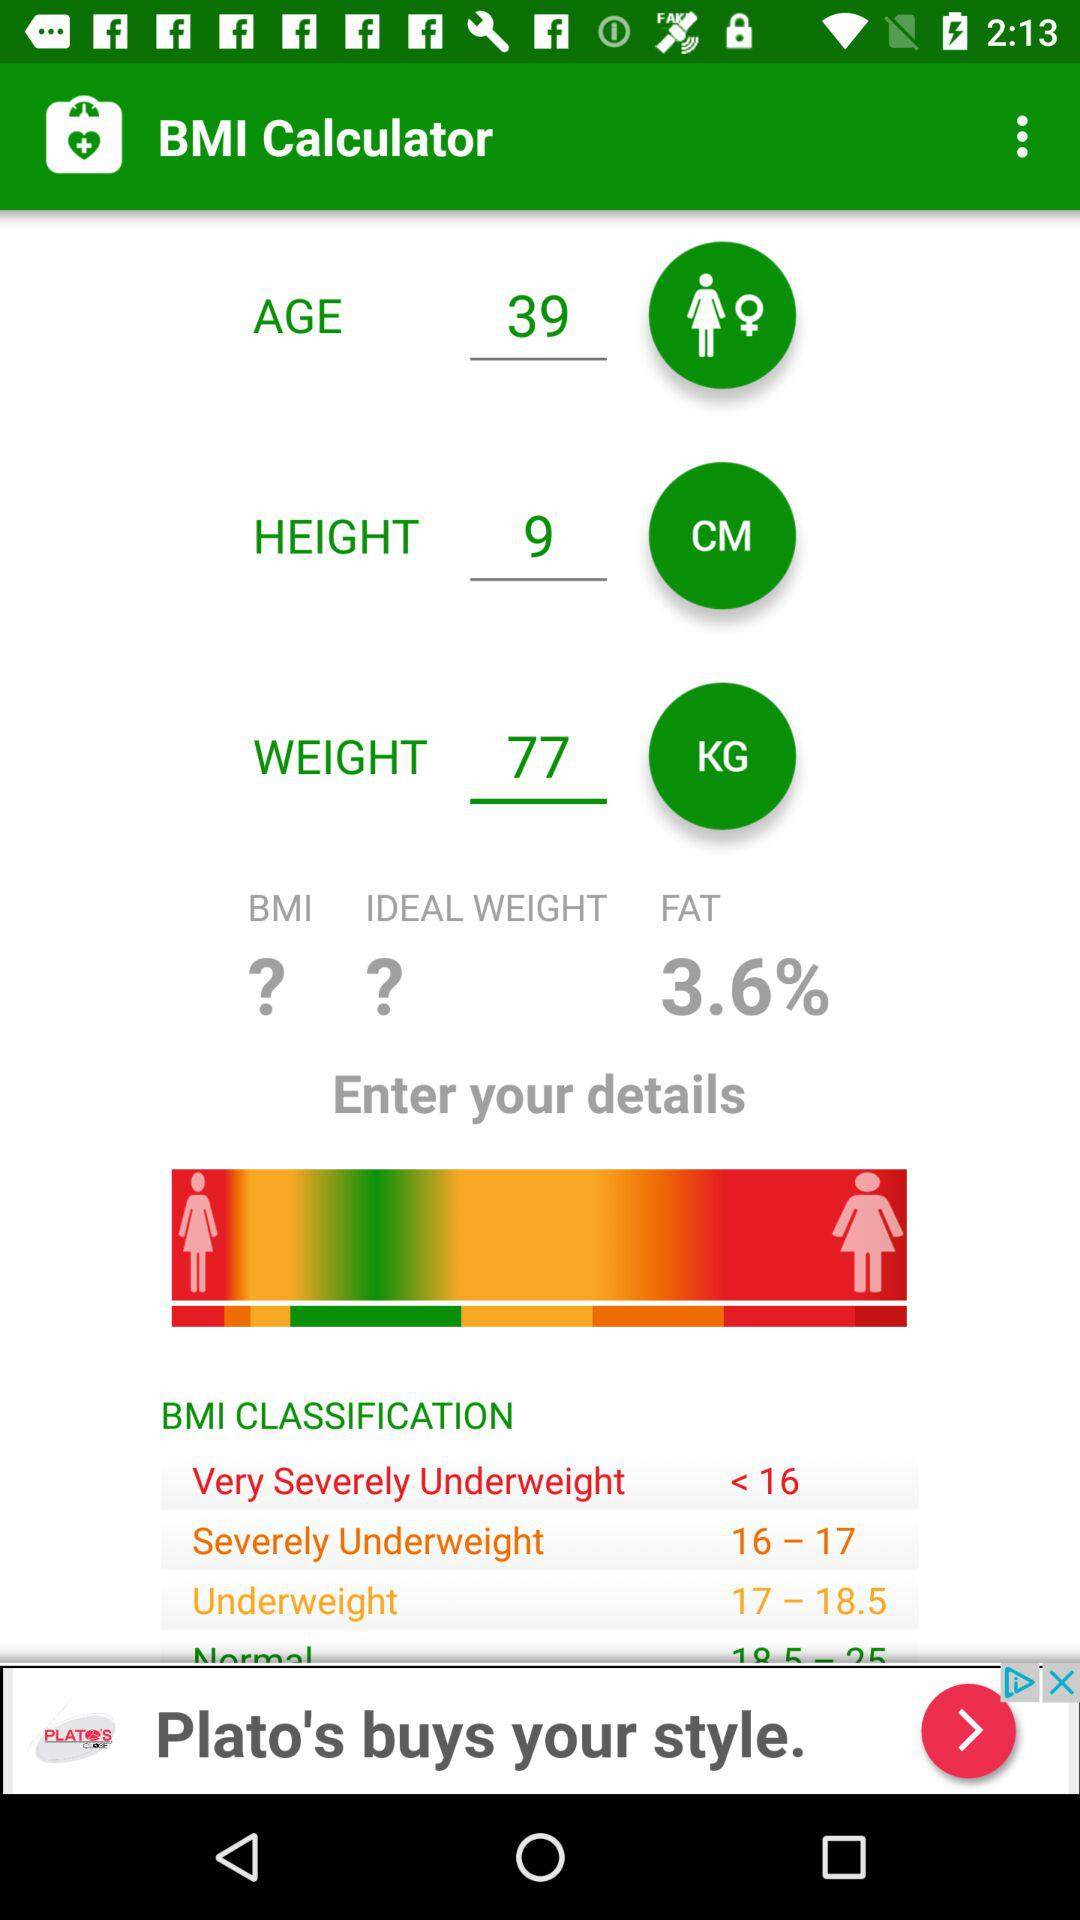How much fat is present? There is 3.6% fat present. 